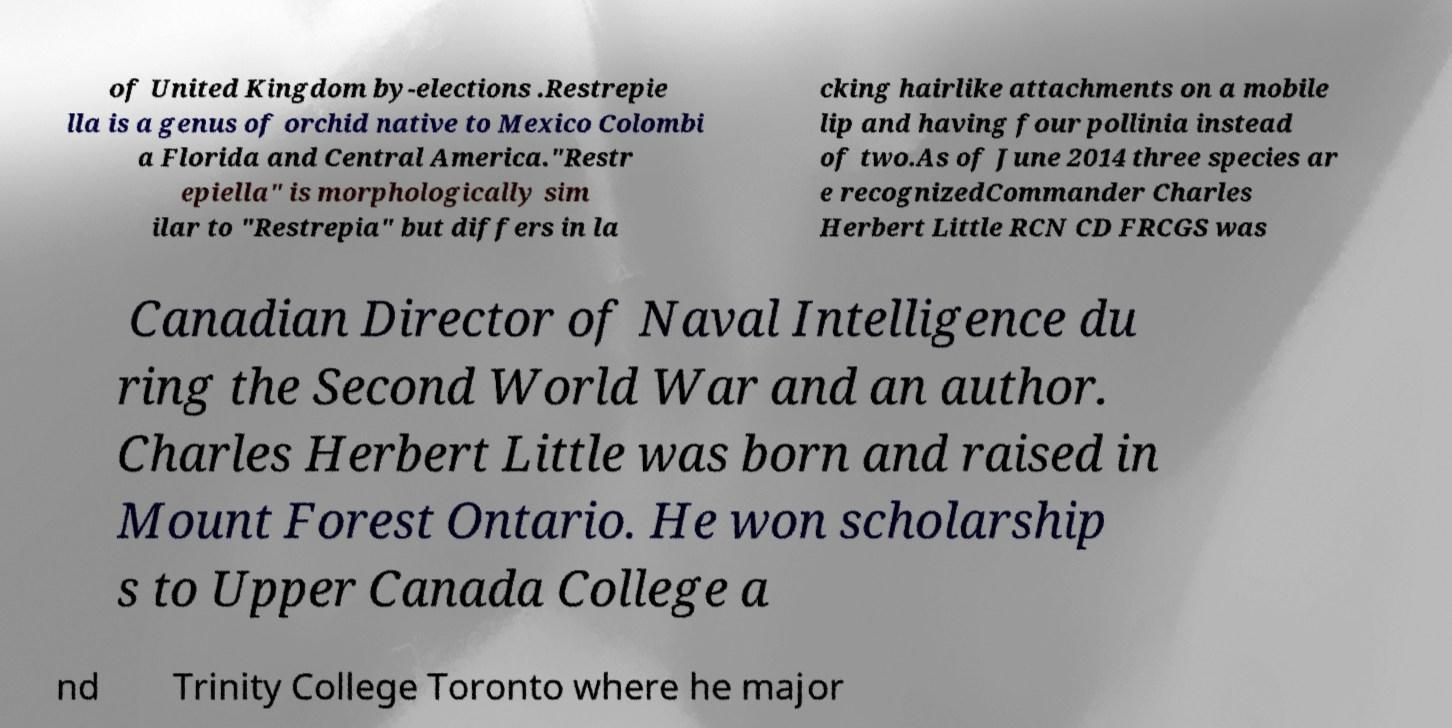Could you assist in decoding the text presented in this image and type it out clearly? of United Kingdom by-elections .Restrepie lla is a genus of orchid native to Mexico Colombi a Florida and Central America."Restr epiella" is morphologically sim ilar to "Restrepia" but differs in la cking hairlike attachments on a mobile lip and having four pollinia instead of two.As of June 2014 three species ar e recognizedCommander Charles Herbert Little RCN CD FRCGS was Canadian Director of Naval Intelligence du ring the Second World War and an author. Charles Herbert Little was born and raised in Mount Forest Ontario. He won scholarship s to Upper Canada College a nd Trinity College Toronto where he major 